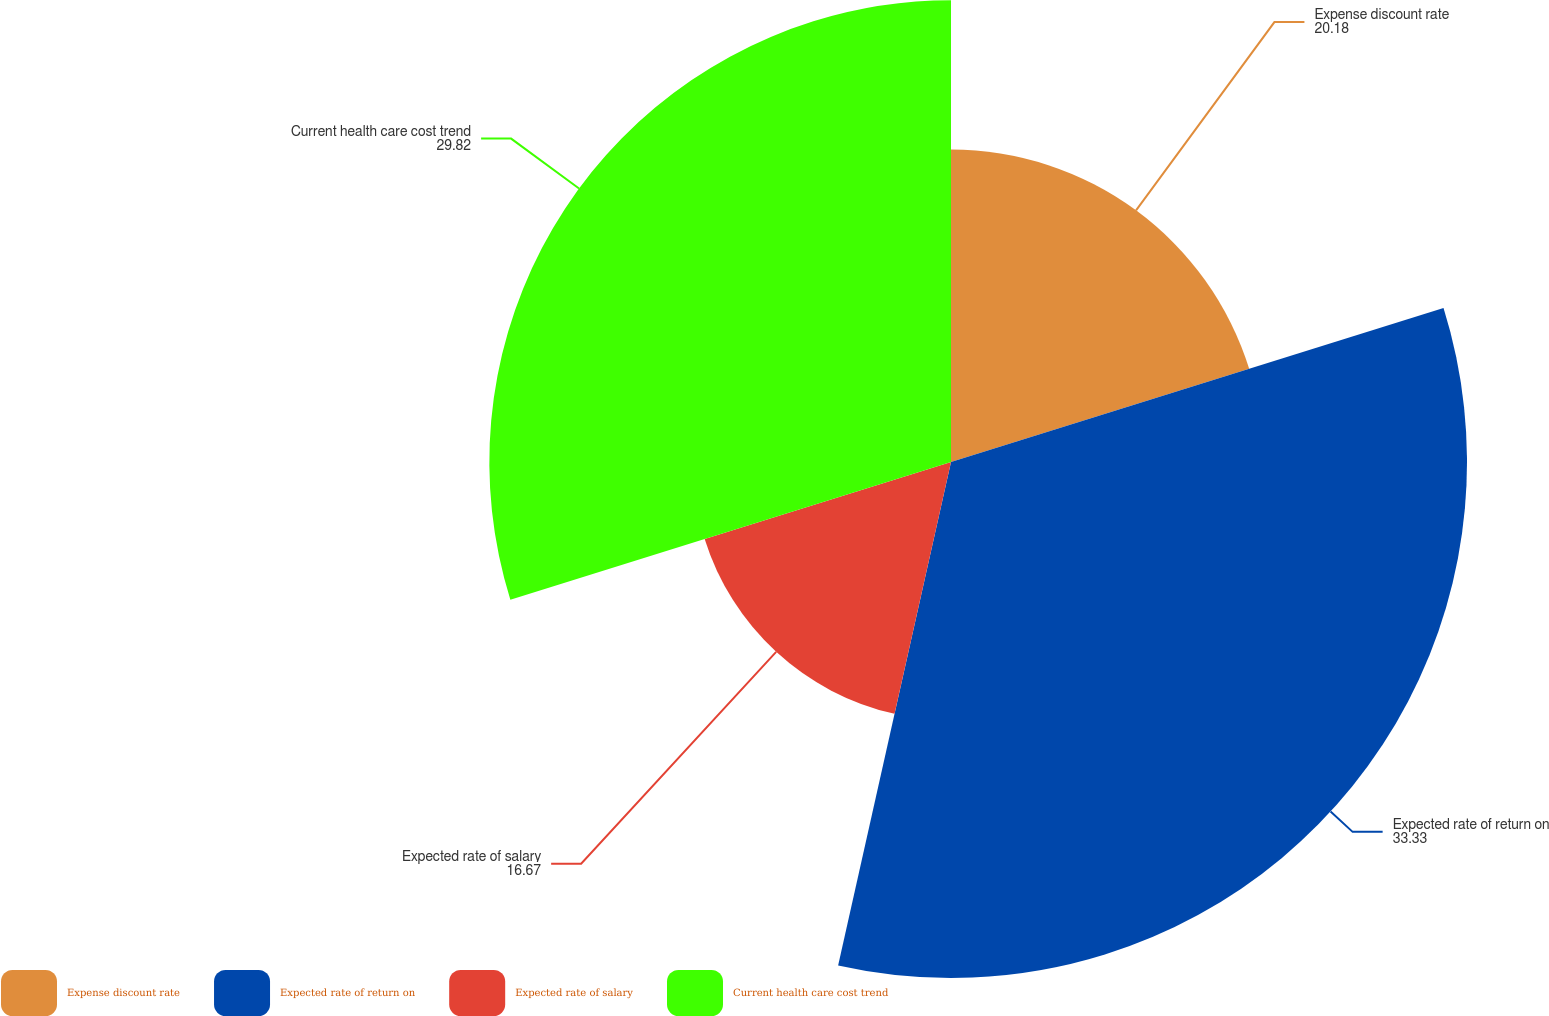Convert chart. <chart><loc_0><loc_0><loc_500><loc_500><pie_chart><fcel>Expense discount rate<fcel>Expected rate of return on<fcel>Expected rate of salary<fcel>Current health care cost trend<nl><fcel>20.18%<fcel>33.33%<fcel>16.67%<fcel>29.82%<nl></chart> 